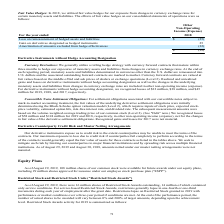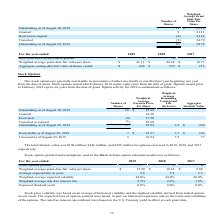Looking at Micron Technology's financial data, please calculate: What is the total price of granted and restrictions lapsed stocks? Based on the calculation: (9*41.11)+(-6*24.22) , the result is 224.67 (in millions). This is based on the information: "Restrictions lapsed (6) 24.22 Restrictions lapsed (6) 24.22 Granted 9 41.11 Granted 9 41.11..." The key data points involved are: 24.22, 41.11, 9. Also, can you calculate: What is the percentage change of the number of Restricted Stock Awards shares outstanding from August 30, 2018, to August 29, 2019? To answer this question, I need to perform calculations using the financial data. The calculation is: (16-15)/15 , which equals 6.67 (percentage). This is based on the information: "Outstanding as of August 29, 2019 16 34.72 Outstanding as of August 30, 2018 15 $ 25.18..." The key data points involved are: 15, 16. Also, can you calculate: What is the price for service-based Restricted Stock Awards as of August 29, 2019? Based on the calculation: 14*34.72 , the result is 486.08 (in millions). This is based on the information: "Outstanding as of August 29, 2019 16 34.72 on shares of Restricted Stock Awards outstanding, 14 million of which contained..." The key data points involved are: 14, 34.72. Also, How many Restricted Stock Awards of shares were outstanding as of August 29, 2019? According to the financial document, 16 million shares. The relevant text states: "As of August 29, 2019, there were 16 million shares of Restricted Stock Awards outstanding, 14 million of which contained..." Also, What is the Weighted-Average Grant Date Fair Value Per Share for Granted stocks? According to the financial document, 41.11. The relevant text states: "Granted 9 41.11..." Also, For service-based Restricted Stock Awards, when do the restrictions generally lapse? in one-fourth or one-third increments during each year of employment after the grant date. The document states: "ricted Stock Awards, restrictions generally lapse in one-fourth or one-third increments during each year of employment after the grant date. Restricti..." 